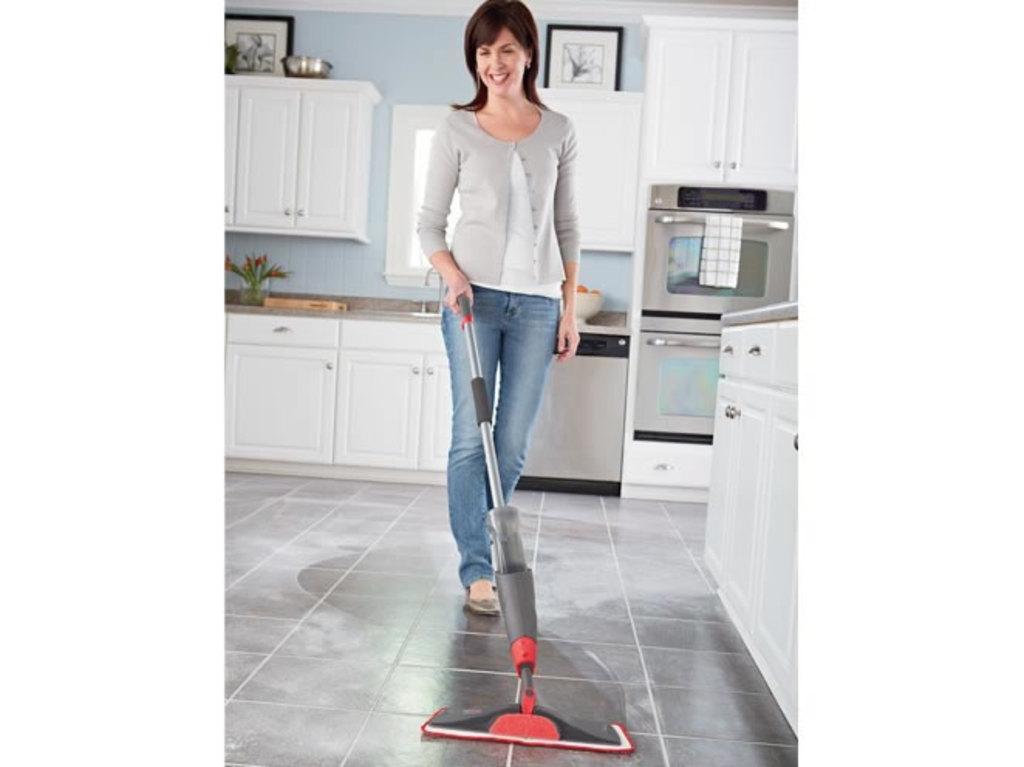Please provide a concise description of this image. In this image woman is cleaning the floor. At the backside of her there is a wooden cupboard. On top of the wooden cupboard there is a sink. Beside the sink there is a bowl full of fruits and there is a flower pot. At the top of the wooden cupboard there is a photo frame. Beside the cupboard there is a washing machine. At the right side of the image there is a fridge. 